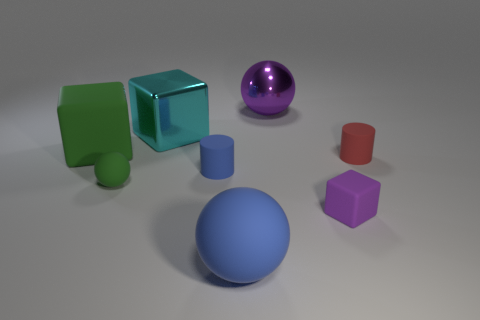Add 1 large red cylinders. How many objects exist? 9 Subtract all large rubber balls. How many balls are left? 2 Subtract all blue cylinders. How many cylinders are left? 1 Subtract all shiny balls. Subtract all small objects. How many objects are left? 3 Add 1 rubber blocks. How many rubber blocks are left? 3 Add 2 tiny matte cubes. How many tiny matte cubes exist? 3 Subtract 0 gray cubes. How many objects are left? 8 Subtract all spheres. How many objects are left? 5 Subtract 1 cylinders. How many cylinders are left? 1 Subtract all purple cubes. Subtract all purple balls. How many cubes are left? 2 